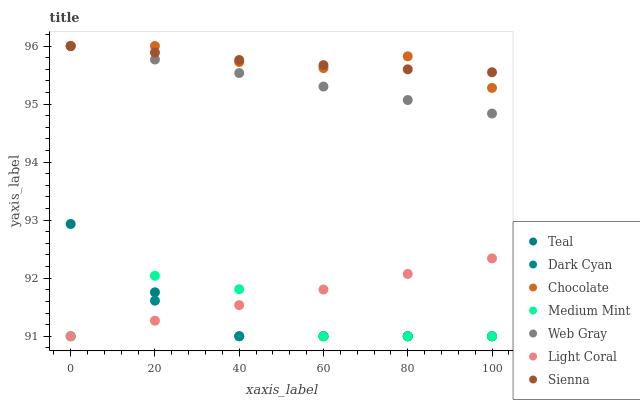Does Dark Cyan have the minimum area under the curve?
Answer yes or no. Yes. Does Chocolate have the maximum area under the curve?
Answer yes or no. Yes. Does Sienna have the minimum area under the curve?
Answer yes or no. No. Does Sienna have the maximum area under the curve?
Answer yes or no. No. Is Web Gray the smoothest?
Answer yes or no. Yes. Is Medium Mint the roughest?
Answer yes or no. Yes. Is Sienna the smoothest?
Answer yes or no. No. Is Sienna the roughest?
Answer yes or no. No. Does Medium Mint have the lowest value?
Answer yes or no. Yes. Does Web Gray have the lowest value?
Answer yes or no. No. Does Chocolate have the highest value?
Answer yes or no. Yes. Does Light Coral have the highest value?
Answer yes or no. No. Is Medium Mint less than Web Gray?
Answer yes or no. Yes. Is Web Gray greater than Teal?
Answer yes or no. Yes. Does Medium Mint intersect Light Coral?
Answer yes or no. Yes. Is Medium Mint less than Light Coral?
Answer yes or no. No. Is Medium Mint greater than Light Coral?
Answer yes or no. No. Does Medium Mint intersect Web Gray?
Answer yes or no. No. 